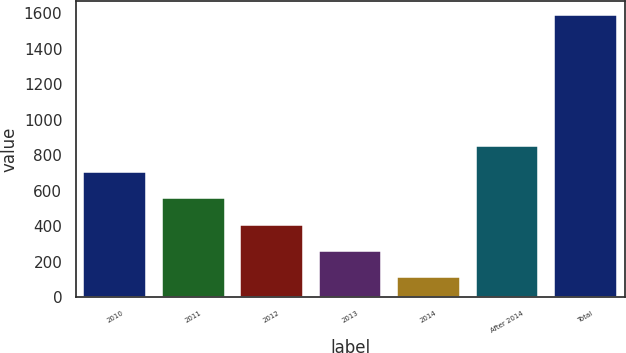Convert chart. <chart><loc_0><loc_0><loc_500><loc_500><bar_chart><fcel>2010<fcel>2011<fcel>2012<fcel>2013<fcel>2014<fcel>After 2014<fcel>Total<nl><fcel>703.8<fcel>556.1<fcel>408.4<fcel>260.7<fcel>113<fcel>851.5<fcel>1590<nl></chart> 